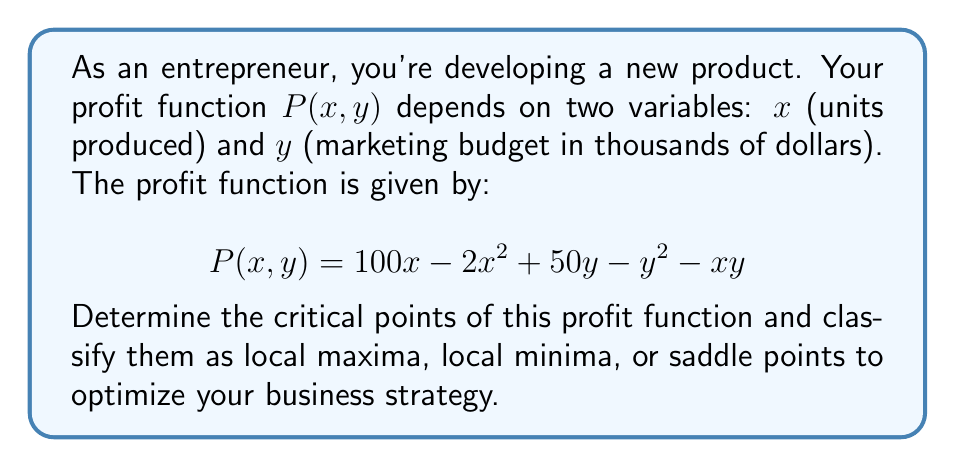Can you solve this math problem? 1. Find the partial derivatives:
   $$\frac{\partial P}{\partial x} = 100 - 4x - y$$
   $$\frac{\partial P}{\partial y} = 50 - 2y - x$$

2. Set both partial derivatives to zero and solve the system of equations:
   $$100 - 4x - y = 0$$
   $$50 - 2y - x = 0$$

3. Solve for x and y:
   From the second equation: $x = 50 - 2y$
   Substitute into the first equation:
   $$100 - 4(50 - 2y) - y = 0$$
   $$100 - 200 + 8y - y = 0$$
   $$7y = 100$$
   $$y = \frac{100}{7} \approx 14.29$$
   
   Substitute back to find x:
   $$x = 50 - 2(\frac{100}{7}) = \frac{250}{7} \approx 35.71$$

4. The critical point is $(\frac{250}{7}, \frac{100}{7})$.

5. To classify this point, we need to evaluate the Hessian matrix:
   $$H = \begin{bmatrix} 
   \frac{\partial^2 P}{\partial x^2} & \frac{\partial^2 P}{\partial x \partial y} \\
   \frac{\partial^2 P}{\partial y \partial x} & \frac{\partial^2 P}{\partial y^2}
   \end{bmatrix} = \begin{bmatrix}
   -4 & -1 \\
   -1 & -2
   \end{bmatrix}$$

6. Calculate the determinant of H:
   $$\det(H) = (-4)(-2) - (-1)(-1) = 8 - 1 = 7 > 0$$

7. Since $\det(H) > 0$ and $\frac{\partial^2 P}{\partial x^2} = -4 < 0$, the critical point is a local maximum.
Answer: Local maximum at $(\frac{250}{7}, \frac{100}{7})$ 